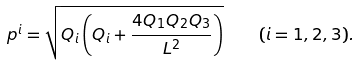<formula> <loc_0><loc_0><loc_500><loc_500>p ^ { i } = \sqrt { Q _ { i } \left ( Q _ { i } + \frac { 4 Q _ { 1 } Q _ { 2 } Q _ { 3 } } { L ^ { 2 } } \right ) } \quad ( i = 1 , 2 , 3 ) .</formula> 